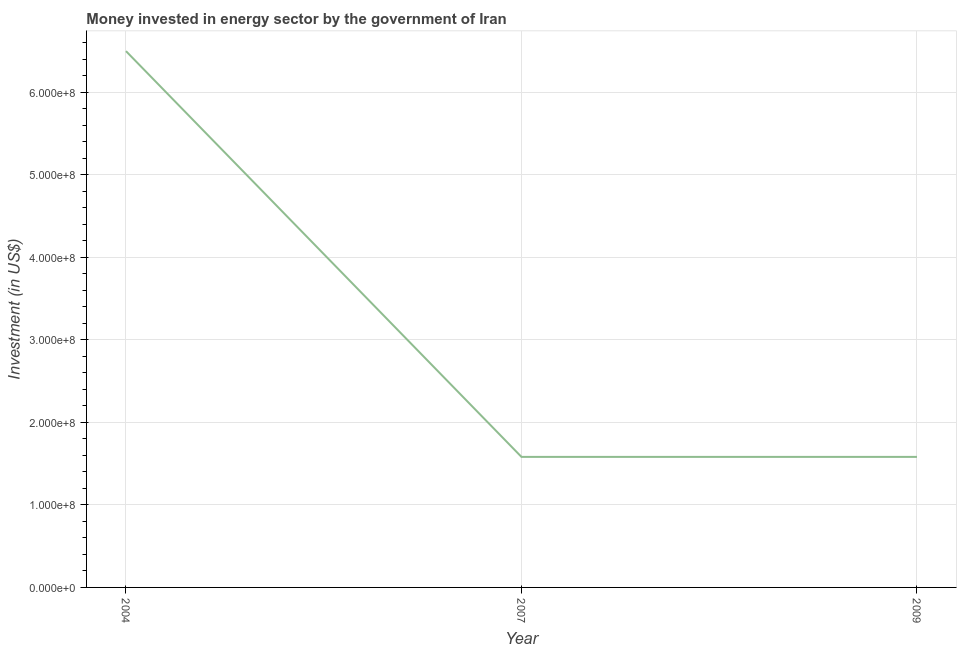What is the investment in energy in 2007?
Make the answer very short. 1.58e+08. Across all years, what is the maximum investment in energy?
Your response must be concise. 6.50e+08. Across all years, what is the minimum investment in energy?
Provide a succinct answer. 1.58e+08. What is the sum of the investment in energy?
Provide a short and direct response. 9.66e+08. What is the difference between the investment in energy in 2004 and 2007?
Ensure brevity in your answer.  4.92e+08. What is the average investment in energy per year?
Make the answer very short. 3.22e+08. What is the median investment in energy?
Give a very brief answer. 1.58e+08. What is the ratio of the investment in energy in 2004 to that in 2007?
Make the answer very short. 4.11. Is the difference between the investment in energy in 2007 and 2009 greater than the difference between any two years?
Give a very brief answer. No. What is the difference between the highest and the second highest investment in energy?
Keep it short and to the point. 4.92e+08. Is the sum of the investment in energy in 2004 and 2007 greater than the maximum investment in energy across all years?
Keep it short and to the point. Yes. What is the difference between the highest and the lowest investment in energy?
Keep it short and to the point. 4.92e+08. In how many years, is the investment in energy greater than the average investment in energy taken over all years?
Your response must be concise. 1. Does the investment in energy monotonically increase over the years?
Give a very brief answer. No. How many years are there in the graph?
Provide a succinct answer. 3. What is the difference between two consecutive major ticks on the Y-axis?
Give a very brief answer. 1.00e+08. Are the values on the major ticks of Y-axis written in scientific E-notation?
Your answer should be compact. Yes. What is the title of the graph?
Provide a succinct answer. Money invested in energy sector by the government of Iran. What is the label or title of the Y-axis?
Provide a short and direct response. Investment (in US$). What is the Investment (in US$) in 2004?
Your response must be concise. 6.50e+08. What is the Investment (in US$) of 2007?
Your answer should be very brief. 1.58e+08. What is the Investment (in US$) in 2009?
Your answer should be compact. 1.58e+08. What is the difference between the Investment (in US$) in 2004 and 2007?
Offer a terse response. 4.92e+08. What is the difference between the Investment (in US$) in 2004 and 2009?
Ensure brevity in your answer.  4.92e+08. What is the difference between the Investment (in US$) in 2007 and 2009?
Your response must be concise. 0. What is the ratio of the Investment (in US$) in 2004 to that in 2007?
Ensure brevity in your answer.  4.11. What is the ratio of the Investment (in US$) in 2004 to that in 2009?
Make the answer very short. 4.11. What is the ratio of the Investment (in US$) in 2007 to that in 2009?
Make the answer very short. 1. 